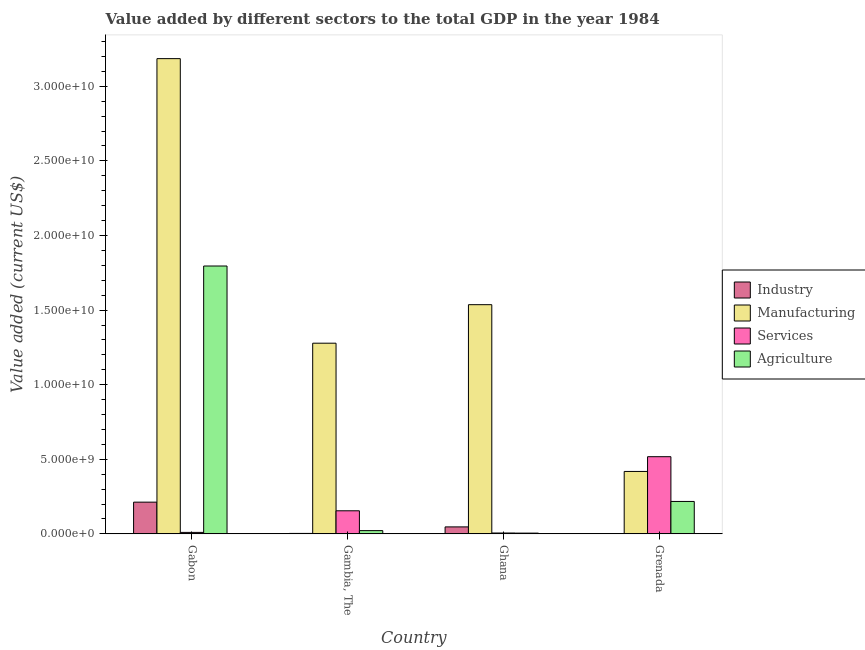How many different coloured bars are there?
Give a very brief answer. 4. How many bars are there on the 3rd tick from the left?
Provide a short and direct response. 4. How many bars are there on the 4th tick from the right?
Ensure brevity in your answer.  4. What is the label of the 4th group of bars from the left?
Your answer should be compact. Grenada. In how many cases, is the number of bars for a given country not equal to the number of legend labels?
Offer a very short reply. 0. What is the value added by industrial sector in Gabon?
Offer a terse response. 2.13e+09. Across all countries, what is the maximum value added by industrial sector?
Your answer should be compact. 2.13e+09. Across all countries, what is the minimum value added by services sector?
Your answer should be compact. 5.77e+07. In which country was the value added by agricultural sector maximum?
Provide a short and direct response. Gabon. In which country was the value added by industrial sector minimum?
Offer a terse response. Grenada. What is the total value added by agricultural sector in the graph?
Keep it short and to the point. 2.04e+1. What is the difference between the value added by manufacturing sector in Gambia, The and that in Grenada?
Your answer should be very brief. 8.60e+09. What is the difference between the value added by industrial sector in Gambia, The and the value added by manufacturing sector in Gabon?
Keep it short and to the point. -3.18e+1. What is the average value added by services sector per country?
Offer a terse response. 1.72e+09. What is the difference between the value added by industrial sector and value added by agricultural sector in Ghana?
Keep it short and to the point. 4.17e+08. In how many countries, is the value added by manufacturing sector greater than 9000000000 US$?
Your answer should be very brief. 3. What is the ratio of the value added by services sector in Gambia, The to that in Ghana?
Provide a succinct answer. 26.82. What is the difference between the highest and the second highest value added by manufacturing sector?
Offer a terse response. 1.65e+1. What is the difference between the highest and the lowest value added by agricultural sector?
Offer a very short reply. 1.79e+1. Is it the case that in every country, the sum of the value added by manufacturing sector and value added by services sector is greater than the sum of value added by agricultural sector and value added by industrial sector?
Provide a succinct answer. Yes. What does the 4th bar from the left in Gabon represents?
Provide a short and direct response. Agriculture. What does the 1st bar from the right in Ghana represents?
Make the answer very short. Agriculture. Is it the case that in every country, the sum of the value added by industrial sector and value added by manufacturing sector is greater than the value added by services sector?
Your answer should be very brief. No. Are all the bars in the graph horizontal?
Offer a terse response. No. How many countries are there in the graph?
Offer a terse response. 4. Does the graph contain any zero values?
Provide a short and direct response. No. Does the graph contain grids?
Provide a succinct answer. No. Where does the legend appear in the graph?
Your response must be concise. Center right. What is the title of the graph?
Keep it short and to the point. Value added by different sectors to the total GDP in the year 1984. Does "WHO" appear as one of the legend labels in the graph?
Provide a succinct answer. No. What is the label or title of the Y-axis?
Your answer should be very brief. Value added (current US$). What is the Value added (current US$) in Industry in Gabon?
Make the answer very short. 2.13e+09. What is the Value added (current US$) of Manufacturing in Gabon?
Make the answer very short. 3.19e+1. What is the Value added (current US$) of Services in Gabon?
Offer a very short reply. 9.82e+07. What is the Value added (current US$) in Agriculture in Gabon?
Your answer should be compact. 1.80e+1. What is the Value added (current US$) in Industry in Gambia, The?
Make the answer very short. 2.95e+07. What is the Value added (current US$) in Manufacturing in Gambia, The?
Provide a short and direct response. 1.28e+1. What is the Value added (current US$) of Services in Gambia, The?
Your response must be concise. 1.55e+09. What is the Value added (current US$) of Agriculture in Gambia, The?
Your answer should be compact. 2.17e+08. What is the Value added (current US$) in Industry in Ghana?
Make the answer very short. 4.67e+08. What is the Value added (current US$) in Manufacturing in Ghana?
Provide a short and direct response. 1.54e+1. What is the Value added (current US$) of Services in Ghana?
Your answer should be very brief. 5.77e+07. What is the Value added (current US$) in Agriculture in Ghana?
Your answer should be very brief. 4.97e+07. What is the Value added (current US$) in Industry in Grenada?
Make the answer very short. 1.52e+07. What is the Value added (current US$) of Manufacturing in Grenada?
Ensure brevity in your answer.  4.18e+09. What is the Value added (current US$) of Services in Grenada?
Make the answer very short. 5.17e+09. What is the Value added (current US$) in Agriculture in Grenada?
Your answer should be very brief. 2.17e+09. Across all countries, what is the maximum Value added (current US$) in Industry?
Your answer should be compact. 2.13e+09. Across all countries, what is the maximum Value added (current US$) of Manufacturing?
Provide a succinct answer. 3.19e+1. Across all countries, what is the maximum Value added (current US$) in Services?
Your response must be concise. 5.17e+09. Across all countries, what is the maximum Value added (current US$) in Agriculture?
Your answer should be compact. 1.80e+1. Across all countries, what is the minimum Value added (current US$) of Industry?
Make the answer very short. 1.52e+07. Across all countries, what is the minimum Value added (current US$) in Manufacturing?
Ensure brevity in your answer.  4.18e+09. Across all countries, what is the minimum Value added (current US$) of Services?
Your answer should be very brief. 5.77e+07. Across all countries, what is the minimum Value added (current US$) in Agriculture?
Offer a very short reply. 4.97e+07. What is the total Value added (current US$) of Industry in the graph?
Provide a succinct answer. 2.64e+09. What is the total Value added (current US$) of Manufacturing in the graph?
Keep it short and to the point. 6.42e+1. What is the total Value added (current US$) in Services in the graph?
Ensure brevity in your answer.  6.87e+09. What is the total Value added (current US$) in Agriculture in the graph?
Offer a very short reply. 2.04e+1. What is the difference between the Value added (current US$) in Industry in Gabon and that in Gambia, The?
Ensure brevity in your answer.  2.10e+09. What is the difference between the Value added (current US$) of Manufacturing in Gabon and that in Gambia, The?
Make the answer very short. 1.91e+1. What is the difference between the Value added (current US$) of Services in Gabon and that in Gambia, The?
Provide a short and direct response. -1.45e+09. What is the difference between the Value added (current US$) in Agriculture in Gabon and that in Gambia, The?
Ensure brevity in your answer.  1.77e+1. What is the difference between the Value added (current US$) in Industry in Gabon and that in Ghana?
Provide a succinct answer. 1.66e+09. What is the difference between the Value added (current US$) of Manufacturing in Gabon and that in Ghana?
Your response must be concise. 1.65e+1. What is the difference between the Value added (current US$) in Services in Gabon and that in Ghana?
Give a very brief answer. 4.05e+07. What is the difference between the Value added (current US$) in Agriculture in Gabon and that in Ghana?
Provide a succinct answer. 1.79e+1. What is the difference between the Value added (current US$) in Industry in Gabon and that in Grenada?
Give a very brief answer. 2.11e+09. What is the difference between the Value added (current US$) of Manufacturing in Gabon and that in Grenada?
Offer a very short reply. 2.77e+1. What is the difference between the Value added (current US$) in Services in Gabon and that in Grenada?
Your answer should be compact. -5.07e+09. What is the difference between the Value added (current US$) of Agriculture in Gabon and that in Grenada?
Provide a short and direct response. 1.58e+1. What is the difference between the Value added (current US$) of Industry in Gambia, The and that in Ghana?
Your answer should be very brief. -4.37e+08. What is the difference between the Value added (current US$) in Manufacturing in Gambia, The and that in Ghana?
Your answer should be compact. -2.58e+09. What is the difference between the Value added (current US$) in Services in Gambia, The and that in Ghana?
Make the answer very short. 1.49e+09. What is the difference between the Value added (current US$) in Agriculture in Gambia, The and that in Ghana?
Your response must be concise. 1.68e+08. What is the difference between the Value added (current US$) in Industry in Gambia, The and that in Grenada?
Your response must be concise. 1.43e+07. What is the difference between the Value added (current US$) in Manufacturing in Gambia, The and that in Grenada?
Keep it short and to the point. 8.60e+09. What is the difference between the Value added (current US$) in Services in Gambia, The and that in Grenada?
Offer a very short reply. -3.63e+09. What is the difference between the Value added (current US$) in Agriculture in Gambia, The and that in Grenada?
Make the answer very short. -1.96e+09. What is the difference between the Value added (current US$) of Industry in Ghana and that in Grenada?
Your response must be concise. 4.52e+08. What is the difference between the Value added (current US$) in Manufacturing in Ghana and that in Grenada?
Your answer should be compact. 1.12e+1. What is the difference between the Value added (current US$) in Services in Ghana and that in Grenada?
Provide a short and direct response. -5.11e+09. What is the difference between the Value added (current US$) in Agriculture in Ghana and that in Grenada?
Provide a succinct answer. -2.12e+09. What is the difference between the Value added (current US$) in Industry in Gabon and the Value added (current US$) in Manufacturing in Gambia, The?
Keep it short and to the point. -1.07e+1. What is the difference between the Value added (current US$) of Industry in Gabon and the Value added (current US$) of Services in Gambia, The?
Offer a very short reply. 5.80e+08. What is the difference between the Value added (current US$) of Industry in Gabon and the Value added (current US$) of Agriculture in Gambia, The?
Ensure brevity in your answer.  1.91e+09. What is the difference between the Value added (current US$) of Manufacturing in Gabon and the Value added (current US$) of Services in Gambia, The?
Ensure brevity in your answer.  3.03e+1. What is the difference between the Value added (current US$) of Manufacturing in Gabon and the Value added (current US$) of Agriculture in Gambia, The?
Ensure brevity in your answer.  3.16e+1. What is the difference between the Value added (current US$) in Services in Gabon and the Value added (current US$) in Agriculture in Gambia, The?
Offer a terse response. -1.19e+08. What is the difference between the Value added (current US$) in Industry in Gabon and the Value added (current US$) in Manufacturing in Ghana?
Ensure brevity in your answer.  -1.32e+1. What is the difference between the Value added (current US$) in Industry in Gabon and the Value added (current US$) in Services in Ghana?
Offer a terse response. 2.07e+09. What is the difference between the Value added (current US$) of Industry in Gabon and the Value added (current US$) of Agriculture in Ghana?
Provide a succinct answer. 2.08e+09. What is the difference between the Value added (current US$) in Manufacturing in Gabon and the Value added (current US$) in Services in Ghana?
Give a very brief answer. 3.18e+1. What is the difference between the Value added (current US$) in Manufacturing in Gabon and the Value added (current US$) in Agriculture in Ghana?
Offer a very short reply. 3.18e+1. What is the difference between the Value added (current US$) of Services in Gabon and the Value added (current US$) of Agriculture in Ghana?
Your answer should be very brief. 4.85e+07. What is the difference between the Value added (current US$) of Industry in Gabon and the Value added (current US$) of Manufacturing in Grenada?
Your answer should be compact. -2.06e+09. What is the difference between the Value added (current US$) of Industry in Gabon and the Value added (current US$) of Services in Grenada?
Give a very brief answer. -3.05e+09. What is the difference between the Value added (current US$) in Industry in Gabon and the Value added (current US$) in Agriculture in Grenada?
Offer a very short reply. -4.67e+07. What is the difference between the Value added (current US$) of Manufacturing in Gabon and the Value added (current US$) of Services in Grenada?
Give a very brief answer. 2.67e+1. What is the difference between the Value added (current US$) of Manufacturing in Gabon and the Value added (current US$) of Agriculture in Grenada?
Keep it short and to the point. 2.97e+1. What is the difference between the Value added (current US$) of Services in Gabon and the Value added (current US$) of Agriculture in Grenada?
Your response must be concise. -2.07e+09. What is the difference between the Value added (current US$) in Industry in Gambia, The and the Value added (current US$) in Manufacturing in Ghana?
Give a very brief answer. -1.53e+1. What is the difference between the Value added (current US$) in Industry in Gambia, The and the Value added (current US$) in Services in Ghana?
Your response must be concise. -2.81e+07. What is the difference between the Value added (current US$) in Industry in Gambia, The and the Value added (current US$) in Agriculture in Ghana?
Offer a very short reply. -2.01e+07. What is the difference between the Value added (current US$) of Manufacturing in Gambia, The and the Value added (current US$) of Services in Ghana?
Your answer should be very brief. 1.27e+1. What is the difference between the Value added (current US$) in Manufacturing in Gambia, The and the Value added (current US$) in Agriculture in Ghana?
Give a very brief answer. 1.27e+1. What is the difference between the Value added (current US$) in Services in Gambia, The and the Value added (current US$) in Agriculture in Ghana?
Keep it short and to the point. 1.50e+09. What is the difference between the Value added (current US$) of Industry in Gambia, The and the Value added (current US$) of Manufacturing in Grenada?
Offer a very short reply. -4.15e+09. What is the difference between the Value added (current US$) in Industry in Gambia, The and the Value added (current US$) in Services in Grenada?
Provide a short and direct response. -5.14e+09. What is the difference between the Value added (current US$) in Industry in Gambia, The and the Value added (current US$) in Agriculture in Grenada?
Offer a terse response. -2.14e+09. What is the difference between the Value added (current US$) in Manufacturing in Gambia, The and the Value added (current US$) in Services in Grenada?
Give a very brief answer. 7.61e+09. What is the difference between the Value added (current US$) of Manufacturing in Gambia, The and the Value added (current US$) of Agriculture in Grenada?
Your response must be concise. 1.06e+1. What is the difference between the Value added (current US$) in Services in Gambia, The and the Value added (current US$) in Agriculture in Grenada?
Make the answer very short. -6.26e+08. What is the difference between the Value added (current US$) of Industry in Ghana and the Value added (current US$) of Manufacturing in Grenada?
Your answer should be very brief. -3.72e+09. What is the difference between the Value added (current US$) of Industry in Ghana and the Value added (current US$) of Services in Grenada?
Your answer should be very brief. -4.71e+09. What is the difference between the Value added (current US$) in Industry in Ghana and the Value added (current US$) in Agriculture in Grenada?
Provide a short and direct response. -1.71e+09. What is the difference between the Value added (current US$) of Manufacturing in Ghana and the Value added (current US$) of Services in Grenada?
Your answer should be compact. 1.02e+1. What is the difference between the Value added (current US$) of Manufacturing in Ghana and the Value added (current US$) of Agriculture in Grenada?
Make the answer very short. 1.32e+1. What is the difference between the Value added (current US$) of Services in Ghana and the Value added (current US$) of Agriculture in Grenada?
Offer a terse response. -2.12e+09. What is the average Value added (current US$) in Industry per country?
Your answer should be compact. 6.59e+08. What is the average Value added (current US$) in Manufacturing per country?
Your answer should be very brief. 1.60e+1. What is the average Value added (current US$) in Services per country?
Offer a very short reply. 1.72e+09. What is the average Value added (current US$) in Agriculture per country?
Ensure brevity in your answer.  5.10e+09. What is the difference between the Value added (current US$) in Industry and Value added (current US$) in Manufacturing in Gabon?
Your answer should be compact. -2.97e+1. What is the difference between the Value added (current US$) in Industry and Value added (current US$) in Services in Gabon?
Offer a terse response. 2.03e+09. What is the difference between the Value added (current US$) of Industry and Value added (current US$) of Agriculture in Gabon?
Ensure brevity in your answer.  -1.58e+1. What is the difference between the Value added (current US$) of Manufacturing and Value added (current US$) of Services in Gabon?
Keep it short and to the point. 3.18e+1. What is the difference between the Value added (current US$) in Manufacturing and Value added (current US$) in Agriculture in Gabon?
Your response must be concise. 1.39e+1. What is the difference between the Value added (current US$) in Services and Value added (current US$) in Agriculture in Gabon?
Give a very brief answer. -1.79e+1. What is the difference between the Value added (current US$) of Industry and Value added (current US$) of Manufacturing in Gambia, The?
Offer a very short reply. -1.28e+1. What is the difference between the Value added (current US$) in Industry and Value added (current US$) in Services in Gambia, The?
Provide a succinct answer. -1.52e+09. What is the difference between the Value added (current US$) in Industry and Value added (current US$) in Agriculture in Gambia, The?
Ensure brevity in your answer.  -1.88e+08. What is the difference between the Value added (current US$) of Manufacturing and Value added (current US$) of Services in Gambia, The?
Offer a very short reply. 1.12e+1. What is the difference between the Value added (current US$) of Manufacturing and Value added (current US$) of Agriculture in Gambia, The?
Give a very brief answer. 1.26e+1. What is the difference between the Value added (current US$) of Services and Value added (current US$) of Agriculture in Gambia, The?
Offer a very short reply. 1.33e+09. What is the difference between the Value added (current US$) in Industry and Value added (current US$) in Manufacturing in Ghana?
Your response must be concise. -1.49e+1. What is the difference between the Value added (current US$) of Industry and Value added (current US$) of Services in Ghana?
Your answer should be very brief. 4.09e+08. What is the difference between the Value added (current US$) in Industry and Value added (current US$) in Agriculture in Ghana?
Give a very brief answer. 4.17e+08. What is the difference between the Value added (current US$) of Manufacturing and Value added (current US$) of Services in Ghana?
Offer a terse response. 1.53e+1. What is the difference between the Value added (current US$) in Manufacturing and Value added (current US$) in Agriculture in Ghana?
Make the answer very short. 1.53e+1. What is the difference between the Value added (current US$) in Services and Value added (current US$) in Agriculture in Ghana?
Your answer should be compact. 7.99e+06. What is the difference between the Value added (current US$) in Industry and Value added (current US$) in Manufacturing in Grenada?
Your answer should be very brief. -4.17e+09. What is the difference between the Value added (current US$) of Industry and Value added (current US$) of Services in Grenada?
Your response must be concise. -5.16e+09. What is the difference between the Value added (current US$) in Industry and Value added (current US$) in Agriculture in Grenada?
Provide a succinct answer. -2.16e+09. What is the difference between the Value added (current US$) in Manufacturing and Value added (current US$) in Services in Grenada?
Your answer should be compact. -9.88e+08. What is the difference between the Value added (current US$) of Manufacturing and Value added (current US$) of Agriculture in Grenada?
Your answer should be very brief. 2.01e+09. What is the difference between the Value added (current US$) in Services and Value added (current US$) in Agriculture in Grenada?
Offer a very short reply. 3.00e+09. What is the ratio of the Value added (current US$) of Industry in Gabon to that in Gambia, The?
Your answer should be very brief. 72.02. What is the ratio of the Value added (current US$) of Manufacturing in Gabon to that in Gambia, The?
Ensure brevity in your answer.  2.49. What is the ratio of the Value added (current US$) of Services in Gabon to that in Gambia, The?
Your response must be concise. 0.06. What is the ratio of the Value added (current US$) in Agriculture in Gabon to that in Gambia, The?
Offer a very short reply. 82.59. What is the ratio of the Value added (current US$) of Industry in Gabon to that in Ghana?
Keep it short and to the point. 4.55. What is the ratio of the Value added (current US$) in Manufacturing in Gabon to that in Ghana?
Ensure brevity in your answer.  2.07. What is the ratio of the Value added (current US$) in Services in Gabon to that in Ghana?
Offer a terse response. 1.7. What is the ratio of the Value added (current US$) in Agriculture in Gabon to that in Ghana?
Provide a short and direct response. 361.54. What is the ratio of the Value added (current US$) in Industry in Gabon to that in Grenada?
Provide a short and direct response. 139.74. What is the ratio of the Value added (current US$) in Manufacturing in Gabon to that in Grenada?
Provide a succinct answer. 7.61. What is the ratio of the Value added (current US$) in Services in Gabon to that in Grenada?
Ensure brevity in your answer.  0.02. What is the ratio of the Value added (current US$) of Agriculture in Gabon to that in Grenada?
Make the answer very short. 8.26. What is the ratio of the Value added (current US$) of Industry in Gambia, The to that in Ghana?
Ensure brevity in your answer.  0.06. What is the ratio of the Value added (current US$) in Manufacturing in Gambia, The to that in Ghana?
Offer a very short reply. 0.83. What is the ratio of the Value added (current US$) in Services in Gambia, The to that in Ghana?
Your answer should be compact. 26.82. What is the ratio of the Value added (current US$) in Agriculture in Gambia, The to that in Ghana?
Provide a short and direct response. 4.38. What is the ratio of the Value added (current US$) in Industry in Gambia, The to that in Grenada?
Provide a succinct answer. 1.94. What is the ratio of the Value added (current US$) of Manufacturing in Gambia, The to that in Grenada?
Provide a succinct answer. 3.05. What is the ratio of the Value added (current US$) in Services in Gambia, The to that in Grenada?
Make the answer very short. 0.3. What is the ratio of the Value added (current US$) in Agriculture in Gambia, The to that in Grenada?
Make the answer very short. 0.1. What is the ratio of the Value added (current US$) in Industry in Ghana to that in Grenada?
Your answer should be very brief. 30.69. What is the ratio of the Value added (current US$) of Manufacturing in Ghana to that in Grenada?
Offer a terse response. 3.67. What is the ratio of the Value added (current US$) of Services in Ghana to that in Grenada?
Your response must be concise. 0.01. What is the ratio of the Value added (current US$) of Agriculture in Ghana to that in Grenada?
Your response must be concise. 0.02. What is the difference between the highest and the second highest Value added (current US$) in Industry?
Ensure brevity in your answer.  1.66e+09. What is the difference between the highest and the second highest Value added (current US$) in Manufacturing?
Offer a terse response. 1.65e+1. What is the difference between the highest and the second highest Value added (current US$) in Services?
Ensure brevity in your answer.  3.63e+09. What is the difference between the highest and the second highest Value added (current US$) in Agriculture?
Keep it short and to the point. 1.58e+1. What is the difference between the highest and the lowest Value added (current US$) in Industry?
Your answer should be very brief. 2.11e+09. What is the difference between the highest and the lowest Value added (current US$) in Manufacturing?
Offer a terse response. 2.77e+1. What is the difference between the highest and the lowest Value added (current US$) in Services?
Give a very brief answer. 5.11e+09. What is the difference between the highest and the lowest Value added (current US$) in Agriculture?
Your response must be concise. 1.79e+1. 